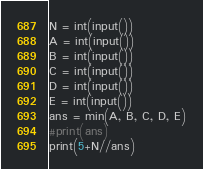<code> <loc_0><loc_0><loc_500><loc_500><_Python_>N = int(input())
A = int(input())
B = int(input())
C = int(input())
D = int(input())
E = int(input())
ans = min(A, B, C, D, E)
#print(ans)
print(5+N//ans)</code> 